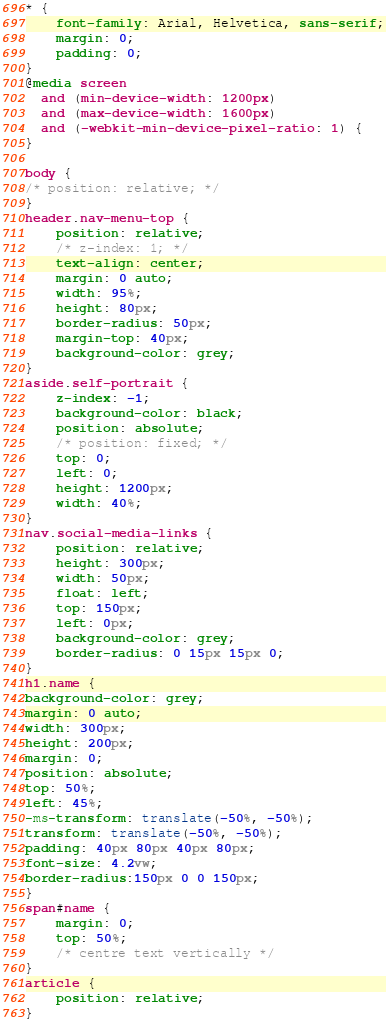Convert code to text. <code><loc_0><loc_0><loc_500><loc_500><_CSS_>
* {
    font-family: Arial, Helvetica, sans-serif;
    margin: 0;
    padding: 0;
}
@media screen 
  and (min-device-width: 1200px) 
  and (max-device-width: 1600px) 
  and (-webkit-min-device-pixel-ratio: 1) { 
}

body {
/* position: relative; */
}
header.nav-menu-top {
    position: relative;
    /* z-index: 1; */
    text-align: center;
    margin: 0 auto;
    width: 95%;
    height: 80px;
    border-radius: 50px;
    margin-top: 40px;
    background-color: grey;
}
aside.self-portrait {
    z-index: -1;
    background-color: black;
    position: absolute;
    /* position: fixed; */
    top: 0;
    left: 0;
    height: 1200px;
    width: 40%;
}
nav.social-media-links {
    position: relative;
    height: 300px;
    width: 50px;
    float: left;
    top: 150px;
    left: 0px;
    background-color: grey;
    border-radius: 0 15px 15px 0;
}
h1.name {
background-color: grey;
margin: 0 auto;
width: 300px;
height: 200px;
margin: 0;
position: absolute;
top: 50%;
left: 45%;
-ms-transform: translate(-50%, -50%);
transform: translate(-50%, -50%);
padding: 40px 80px 40px 80px;
font-size: 4.2vw;
border-radius:150px 0 0 150px;
}
span#name {
    margin: 0;
    top: 50%;
    /* centre text vertically */
}
article {
    position: relative;
}</code> 